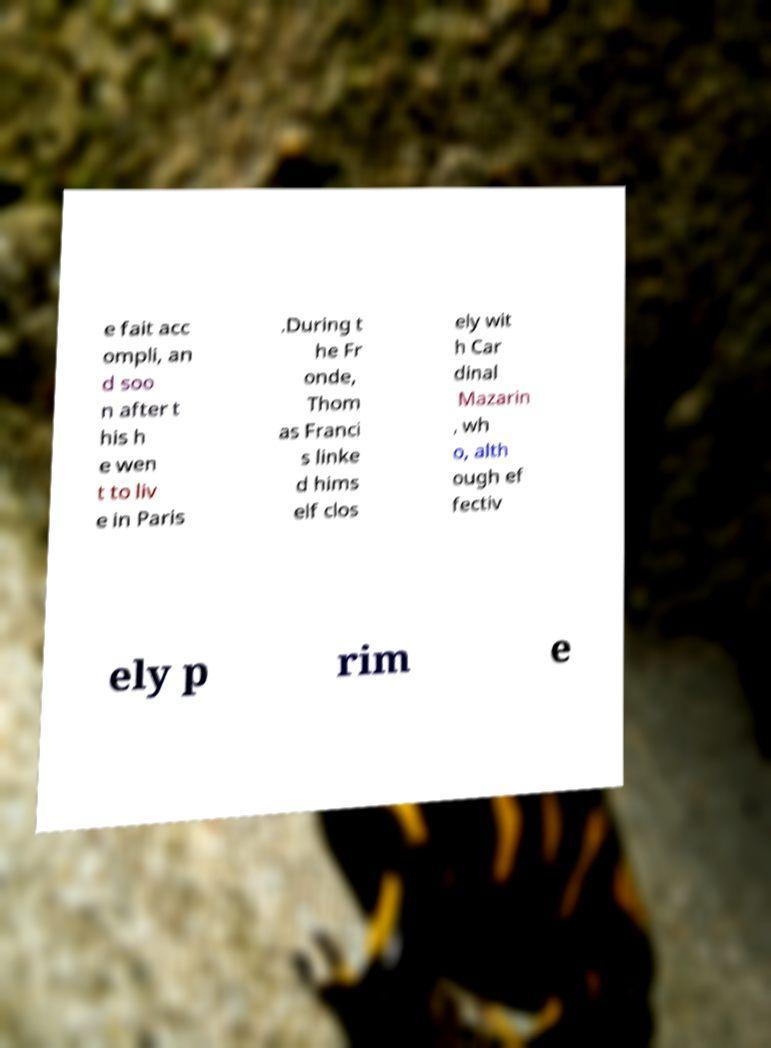I need the written content from this picture converted into text. Can you do that? e fait acc ompli, an d soo n after t his h e wen t to liv e in Paris .During t he Fr onde, Thom as Franci s linke d hims elf clos ely wit h Car dinal Mazarin , wh o, alth ough ef fectiv ely p rim e 